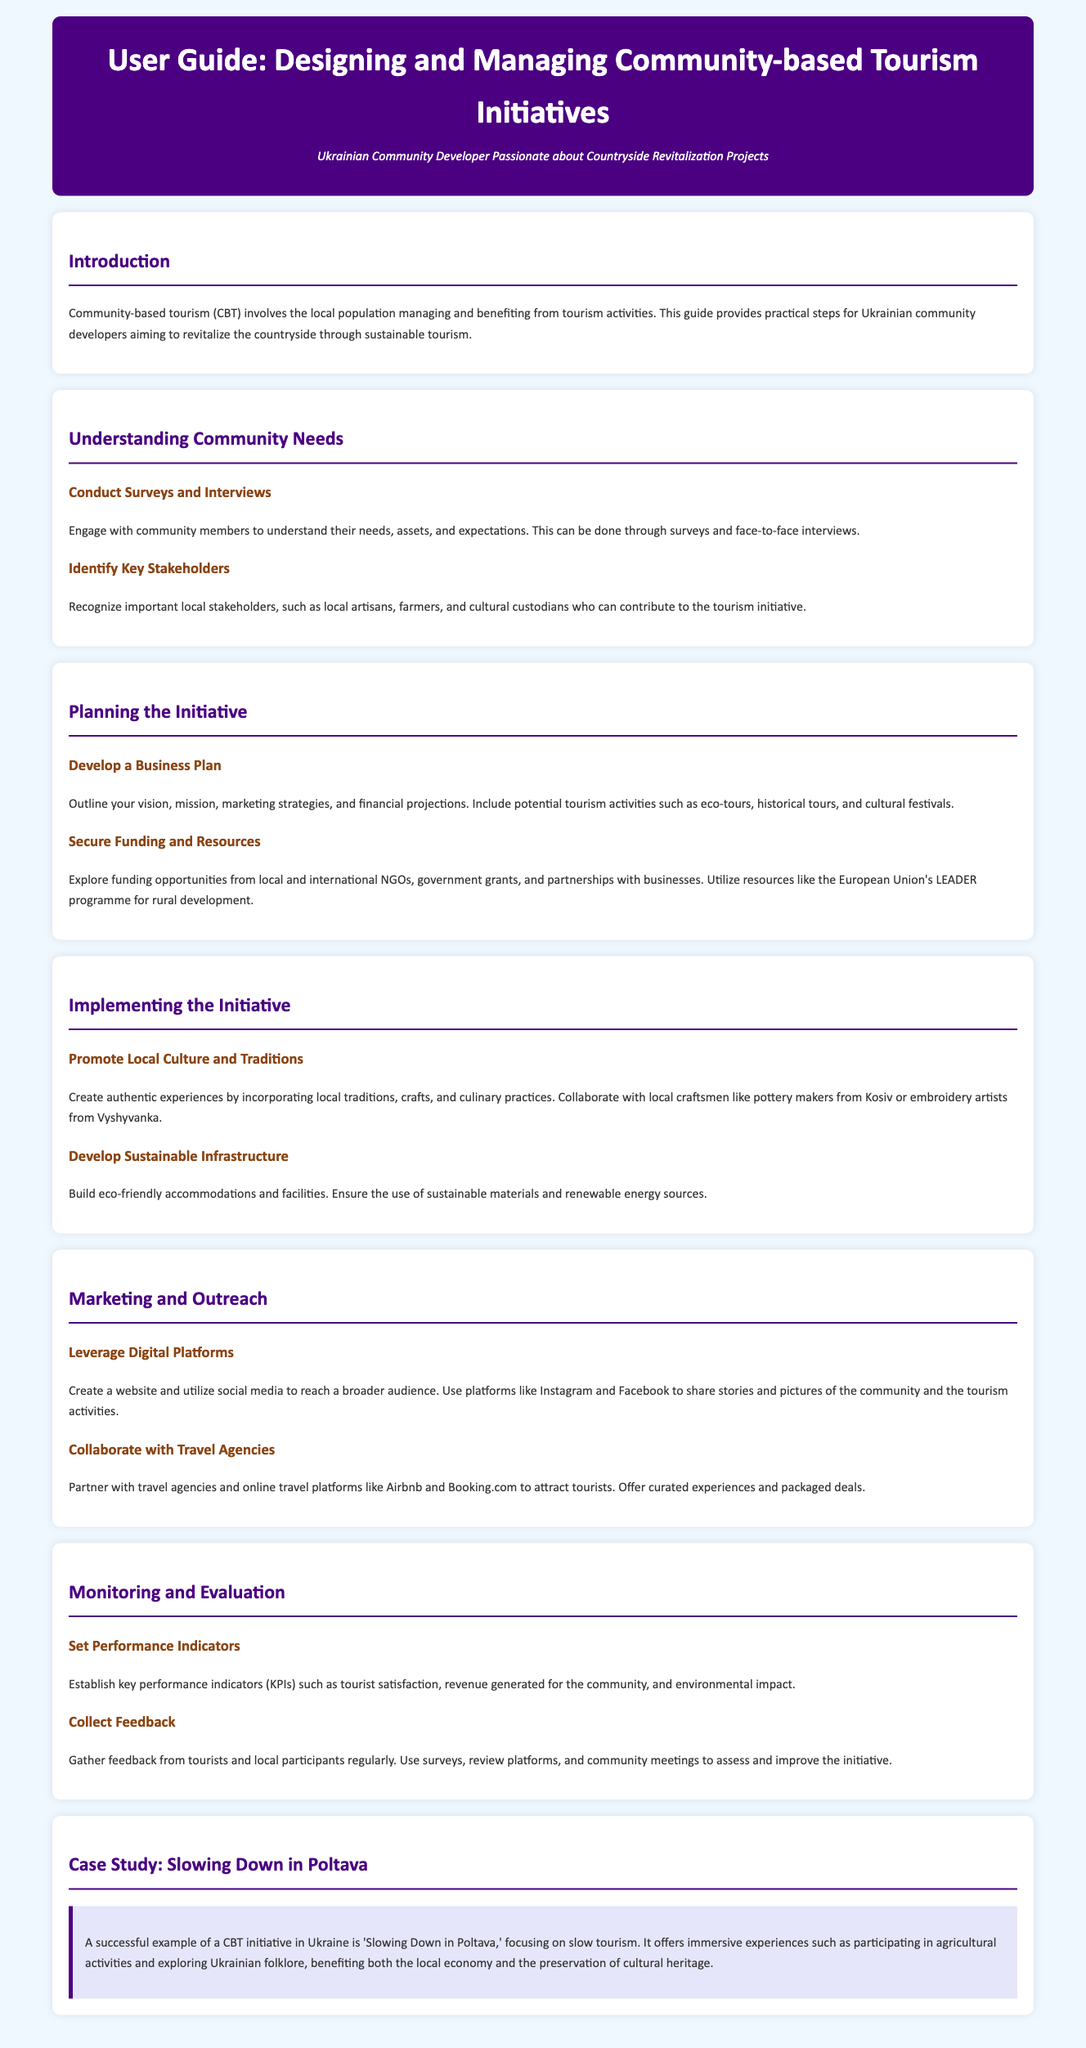what is the title of the user guide? The title of the user guide is found in the header section, which states "User Guide: Designing and Managing Community-based Tourism Initiatives."
Answer: User Guide: Designing and Managing Community-based Tourism Initiatives what is community-based tourism (CBT)? Community-based tourism is described in the introduction as when the local population manages and benefits from tourism activities.
Answer: tourism activities who are some key stakeholders mentioned? The document mentions local artisans, farmers, and cultural custodians as key stakeholders.
Answer: local artisans, farmers, and cultural custodians what type of funding opportunities are suggested? Funding opportunities include local and international NGOs, government grants, and partnerships with businesses as mentioned under "Secure Funding and Resources."
Answer: NGOs, government grants, and partnerships name one example of a promotion strategy. One strategy for promotion is to create a website and utilize social media to reach a broader audience, as stated in the marketing section.
Answer: create a website and utilize social media what are performance indicators (KPIs)? KPIs are described as measures to establish such as tourist satisfaction, revenue generated for the community, and environmental impact.
Answer: tourist satisfaction, revenue generated, environmental impact what project is highlighted as a case study? The case study featured is "Slowing Down in Poltava," which focuses on slow tourism.
Answer: Slowing Down in Poltava which cultural traditions are suggested to be included? The document suggests promoting local traditions, crafts, and culinary practices for authentic experiences.
Answer: local traditions, crafts, and culinary practices 